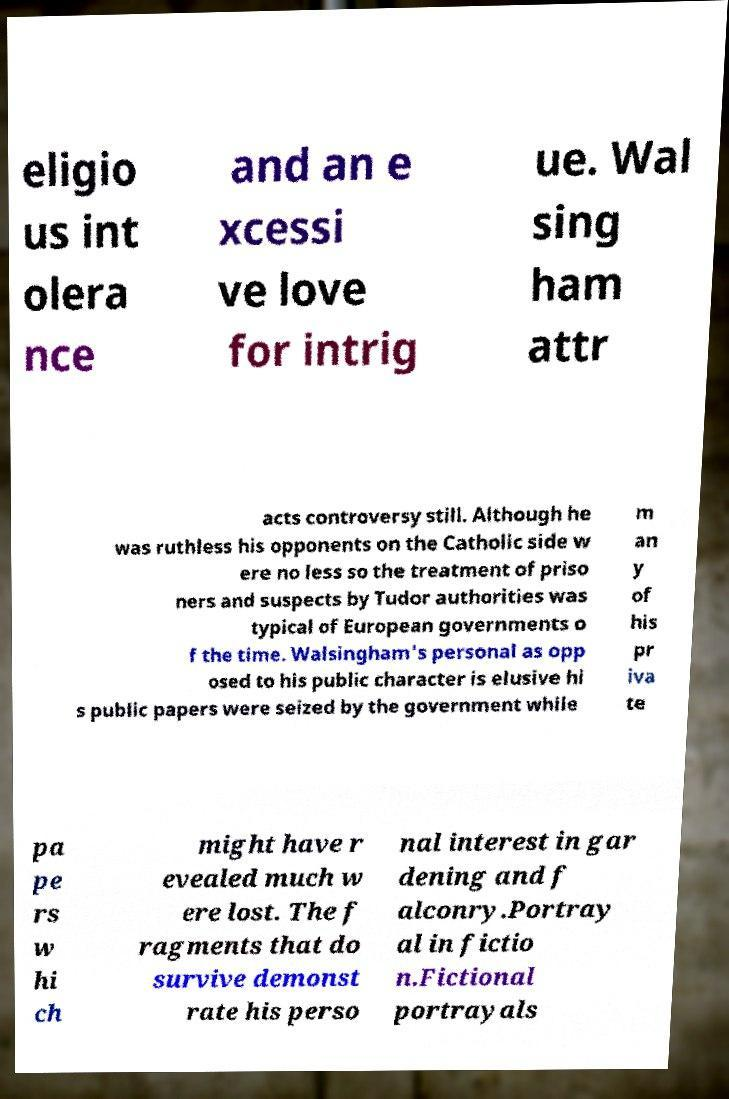Can you read and provide the text displayed in the image?This photo seems to have some interesting text. Can you extract and type it out for me? eligio us int olera nce and an e xcessi ve love for intrig ue. Wal sing ham attr acts controversy still. Although he was ruthless his opponents on the Catholic side w ere no less so the treatment of priso ners and suspects by Tudor authorities was typical of European governments o f the time. Walsingham's personal as opp osed to his public character is elusive hi s public papers were seized by the government while m an y of his pr iva te pa pe rs w hi ch might have r evealed much w ere lost. The f ragments that do survive demonst rate his perso nal interest in gar dening and f alconry.Portray al in fictio n.Fictional portrayals 